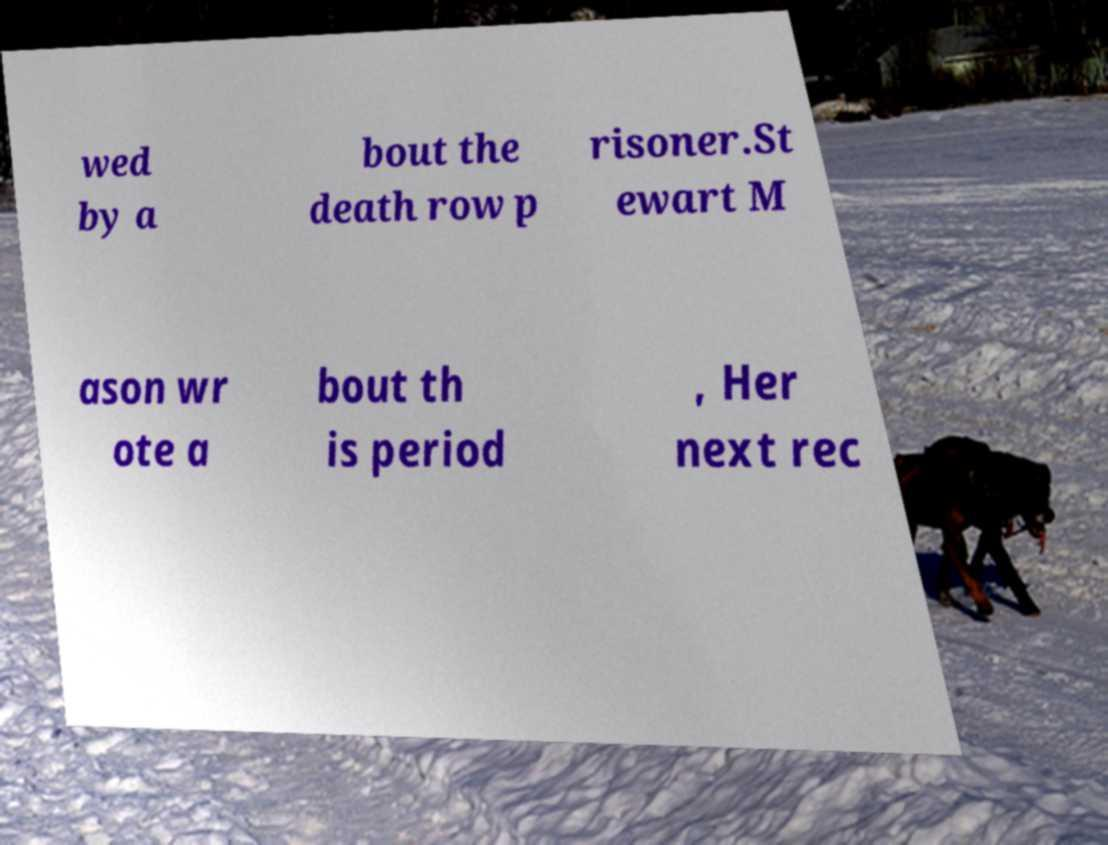There's text embedded in this image that I need extracted. Can you transcribe it verbatim? wed by a bout the death row p risoner.St ewart M ason wr ote a bout th is period , Her next rec 